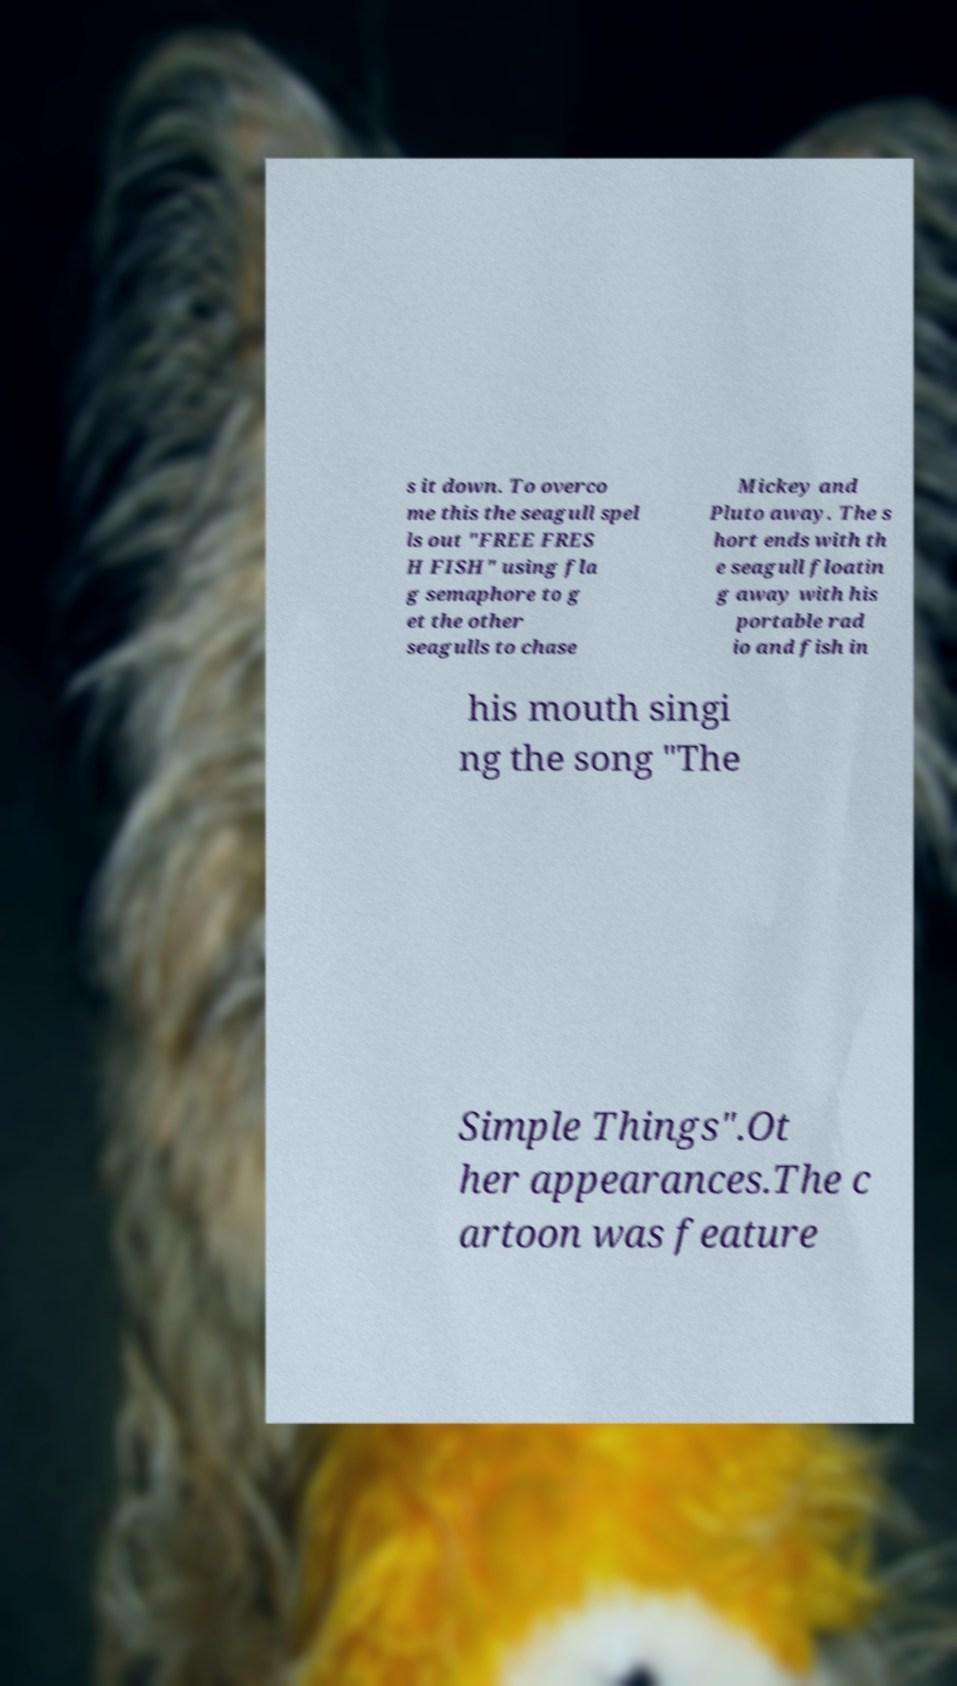Please read and relay the text visible in this image. What does it say? s it down. To overco me this the seagull spel ls out "FREE FRES H FISH" using fla g semaphore to g et the other seagulls to chase Mickey and Pluto away. The s hort ends with th e seagull floatin g away with his portable rad io and fish in his mouth singi ng the song "The Simple Things".Ot her appearances.The c artoon was feature 